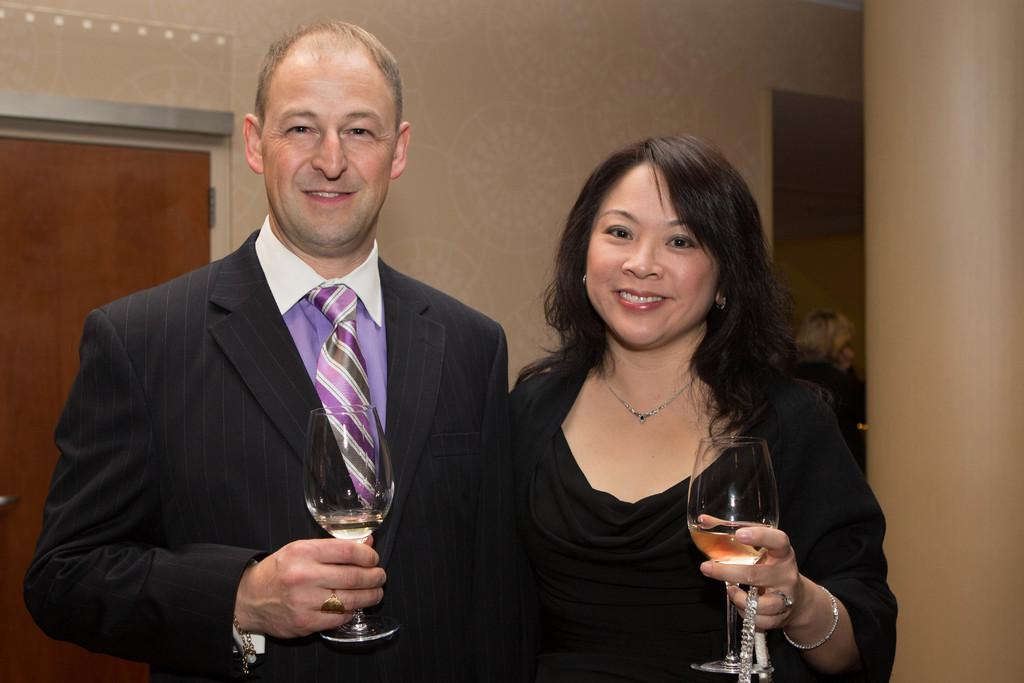How many people are in the image? There are two people in the image, a man and a woman. What are the man and woman holding in their hands? Both the man and woman are holding glasses in their hands. What expressions do the man and woman have? The man and woman are smiling. What can be seen in the background of the image? There is a door, a wall, a frame, and a pillar in the background of the image. What type of fruit is the man holding in his hand? The man is not holding any fruit in his hand; he is holding a glass. 